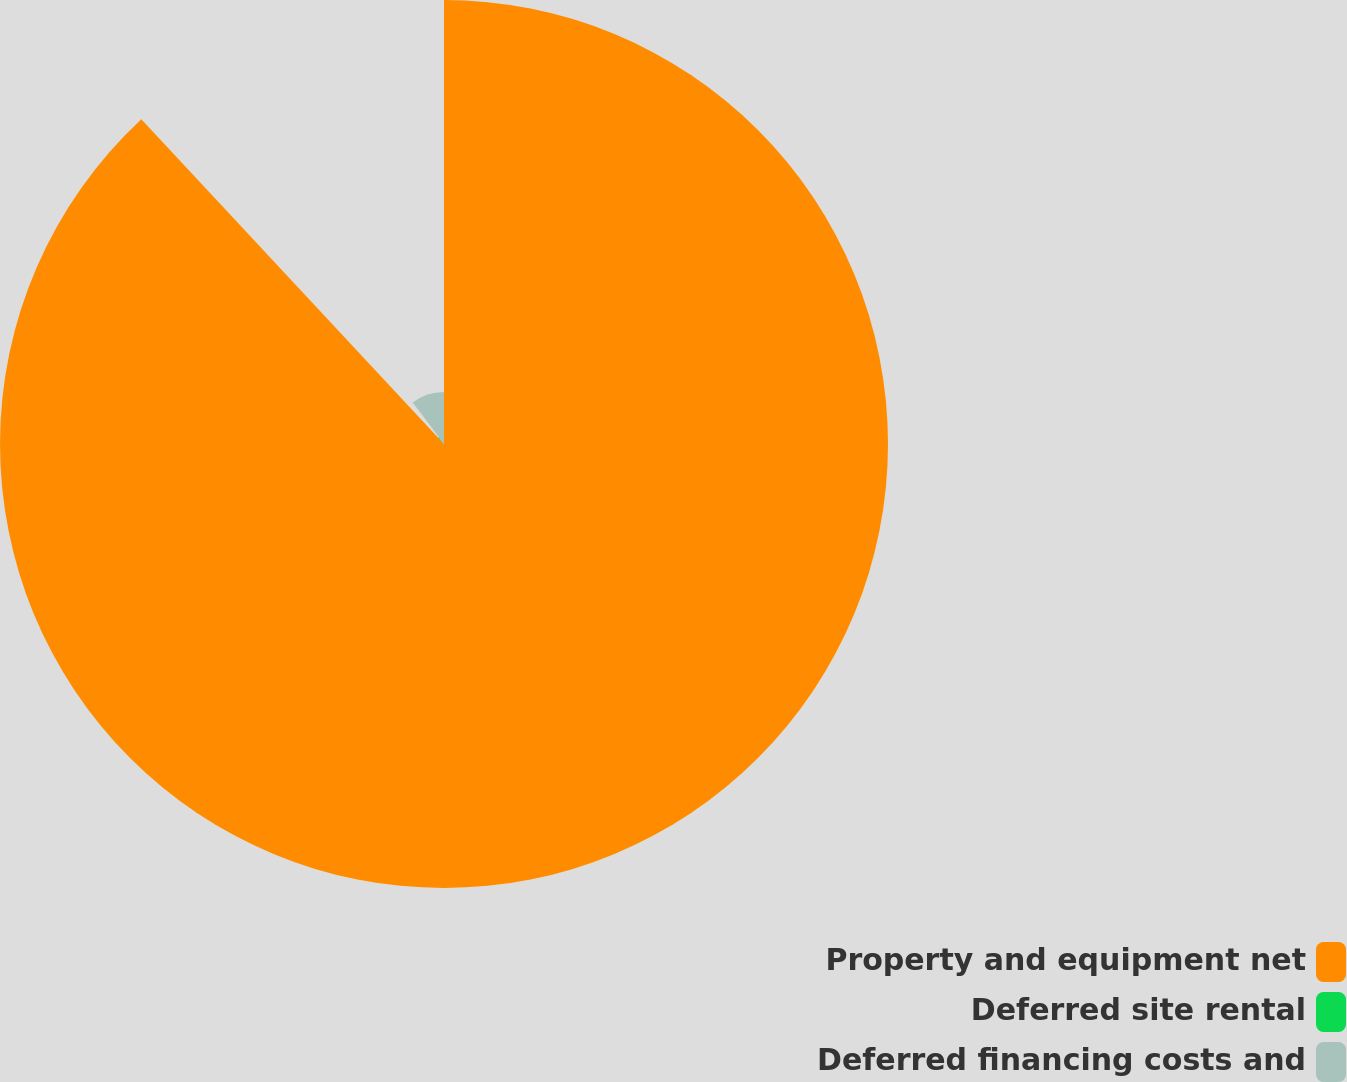Convert chart. <chart><loc_0><loc_0><loc_500><loc_500><pie_chart><fcel>Property and equipment net<fcel>Deferred site rental<fcel>Deferred financing costs and<nl><fcel>88.07%<fcel>1.65%<fcel>10.29%<nl></chart> 